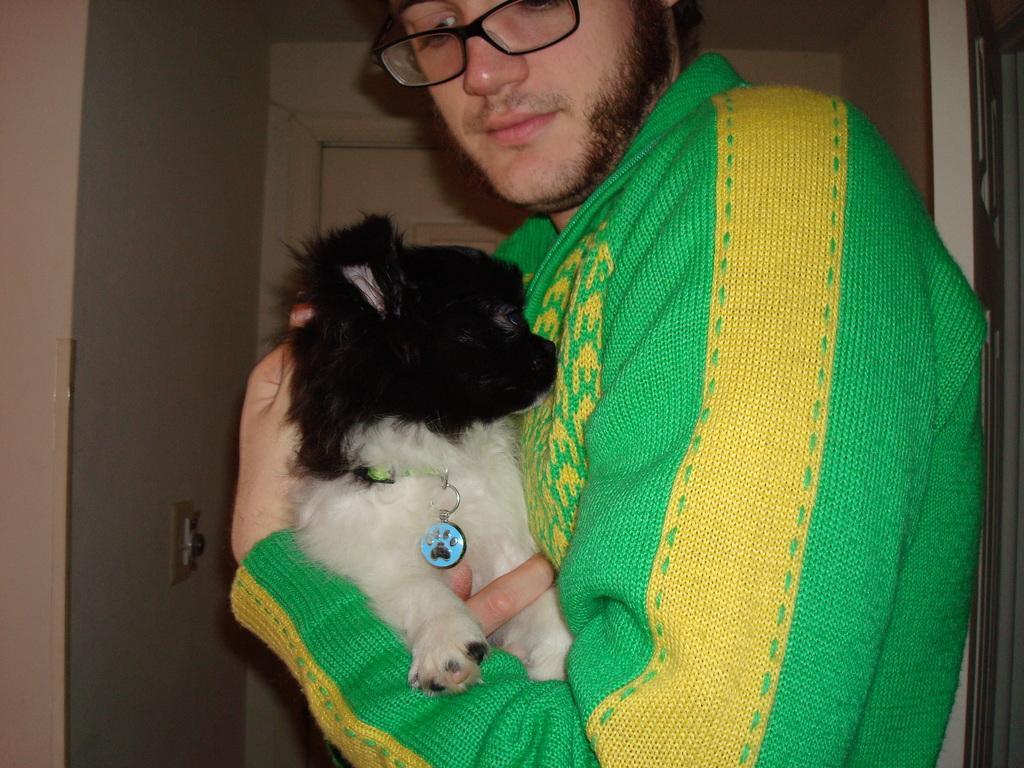How would you summarize this image in a sentence or two? In this image there is a person wearing green colour sweater is holding a dog. He is wearing spectacles. At the background of the image there is a door. 